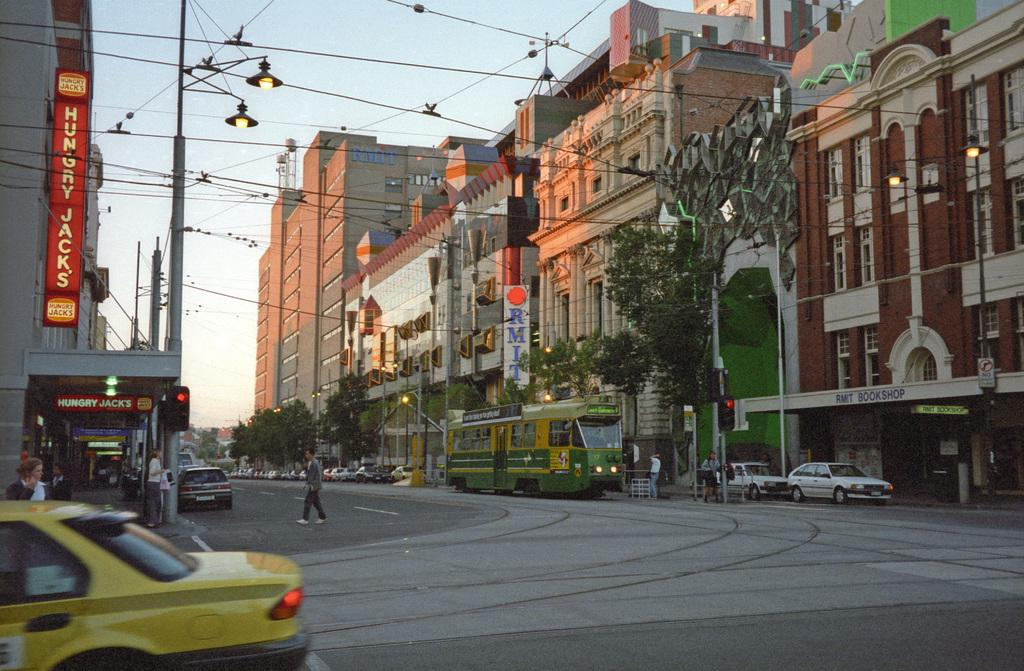<image>
Create a compact narrative representing the image presented. a Hungry Jacks sign that is on a building 